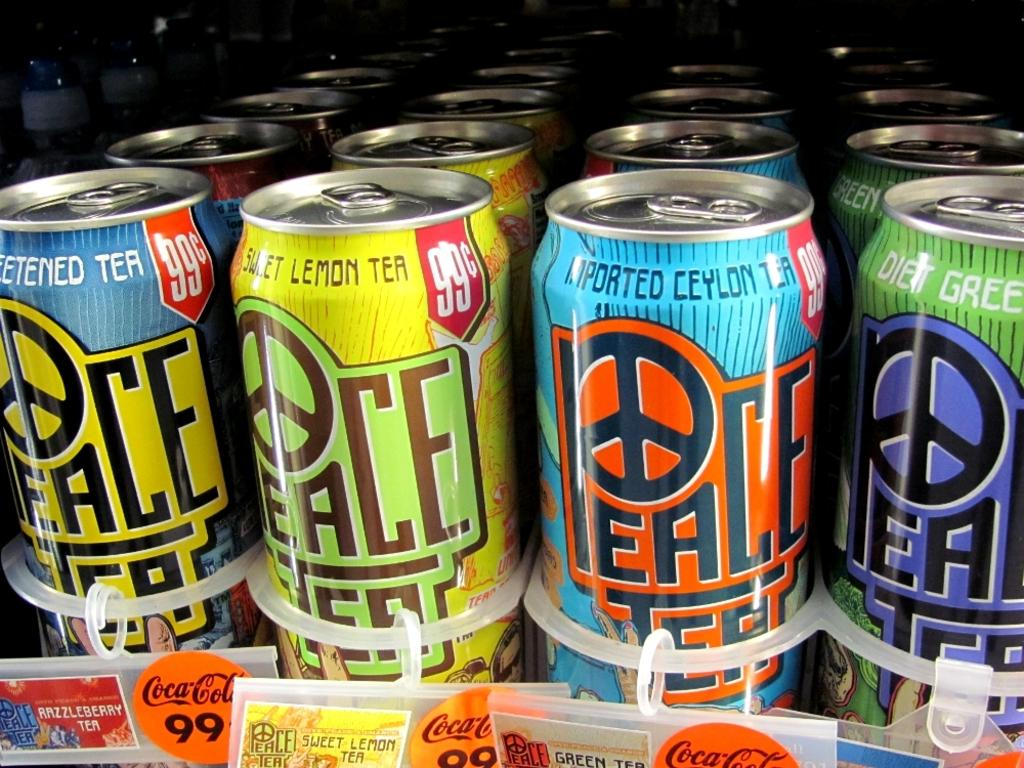<image>
Write a terse but informative summary of the picture. Brightly decorated cans of peace tea in multi-flavors. 